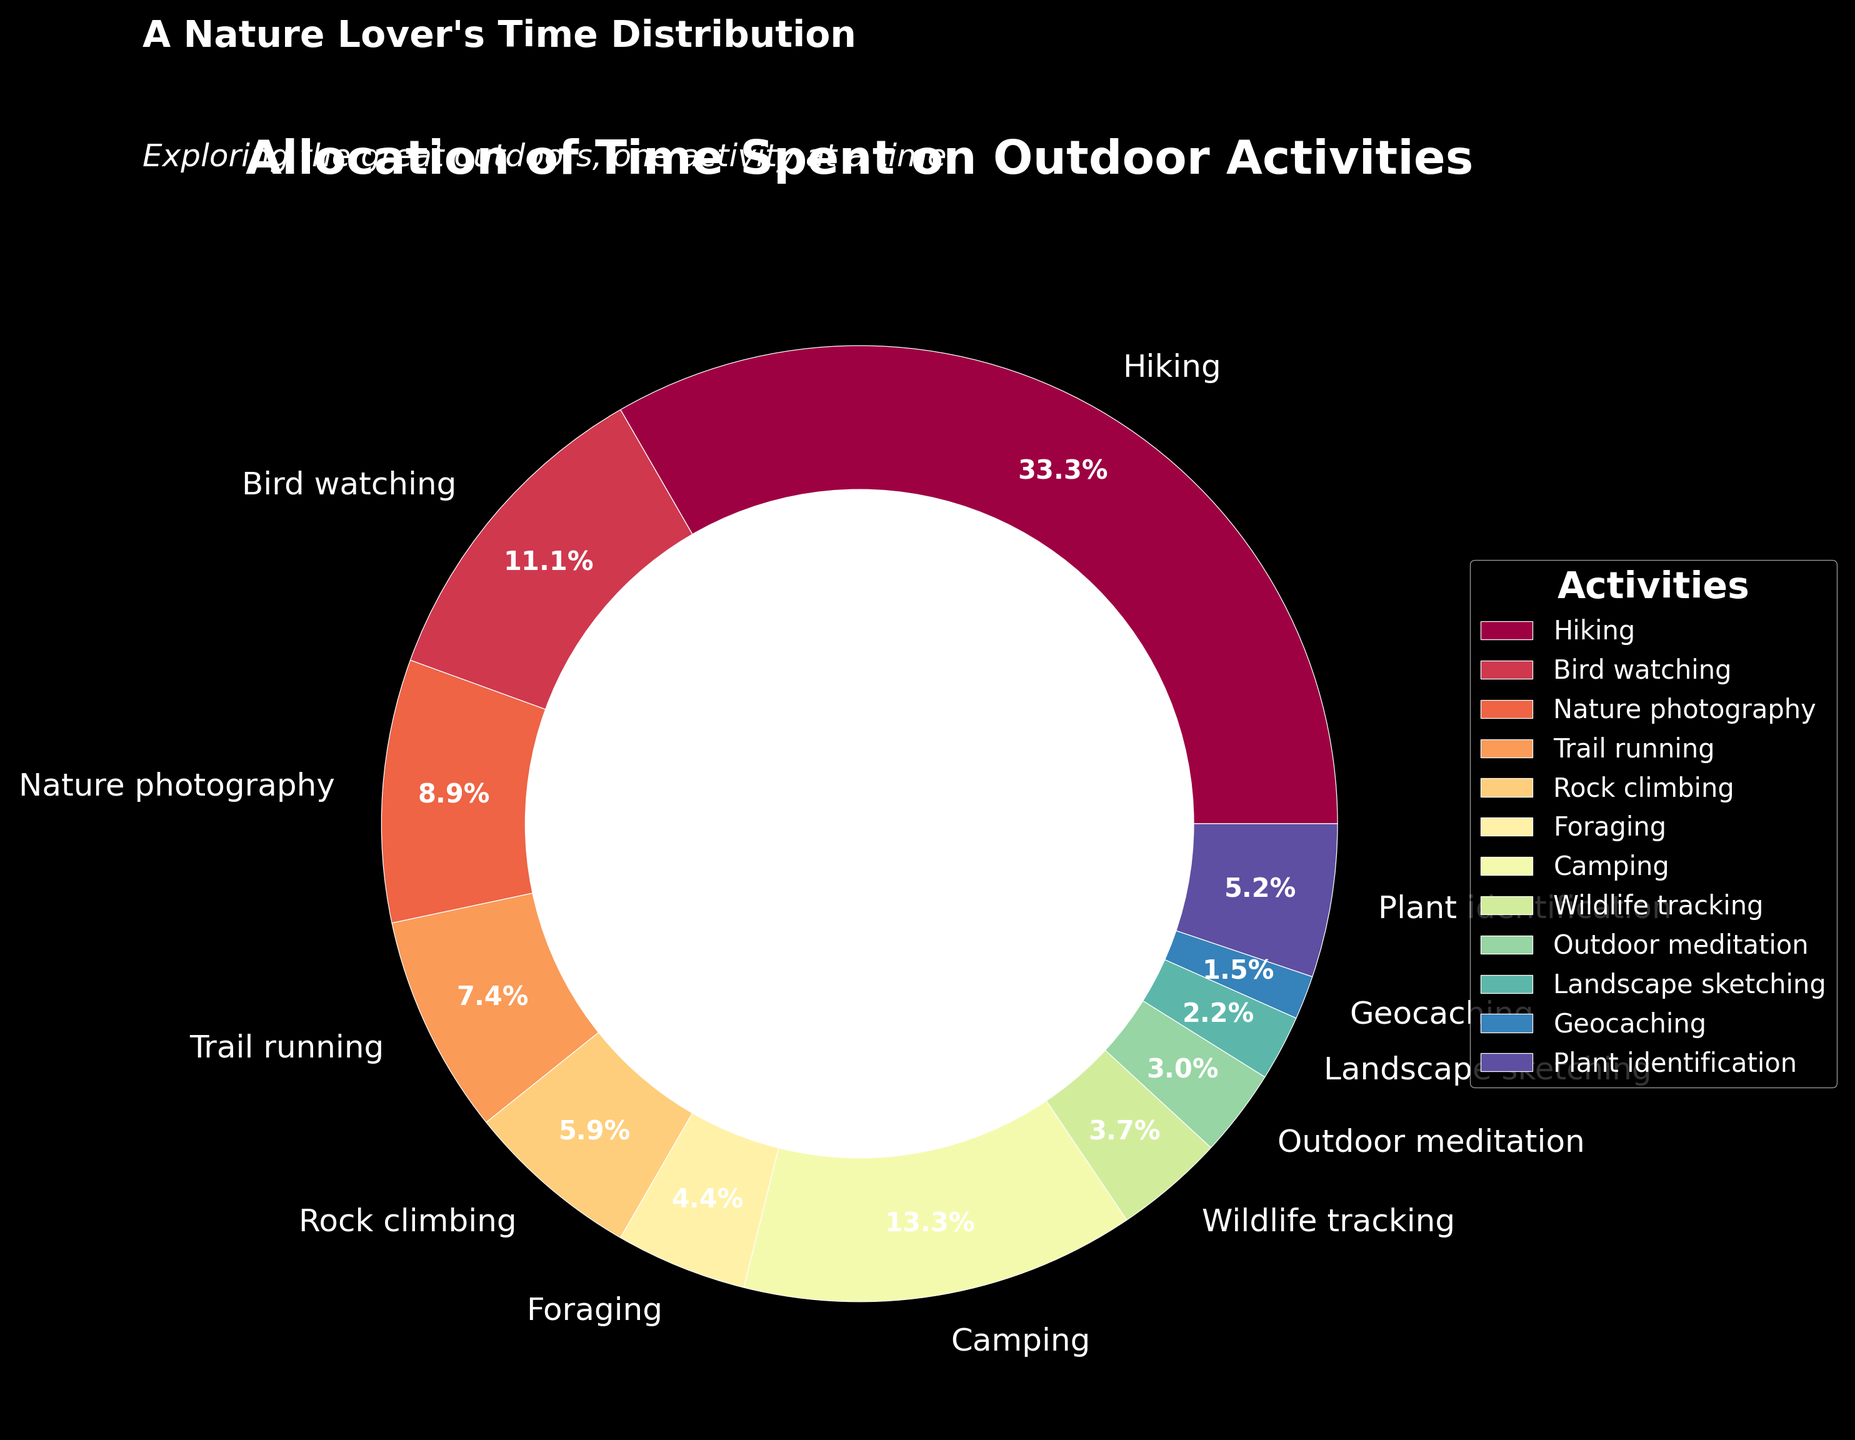What percentage of total time is spent on Camping and Rock climbing combined? First, find the percentage for each activity from the pie chart. Camping is 18 hours out of the total, and Rock climbing is 8 hours. Combined, they sum up to 26 hours. The total hours spent on activities is 135 (by summing all individual hours). Therefore, the percentage is (26 / 135) * 100 ≈ 19.3%
Answer: 19.3% Which activity has the least amount of time allocated, and what percentage of the total does it represent? From the pie chart, Geocaching has the least amount of time allocated, which is 2 hours. The percentage is calculated by (2 / 135) * 100 ≈ 1.5%
Answer: Geocaching, 1.5% How much more time is spent on Hiking compared to Foraging? Hiking is allotted 45 hours, and Foraging is allotted 6 hours. The difference is 45 - 6 = 39 hours
Answer: 39 hours Which activity between Nature photography and Bird watching takes up a larger share in the pie chart, and by how much? Nature Photography is 12 hours, while Bird Watching is 15 hours. Bird Watching takes up a larger share by 15 - 12 = 3 hours
Answer: Bird watching, 3 hours What is the average time spent on the activities that are allocated more than 10 hours? The activities with more than 10 hours are Hiking (45), Bird watching (15), Nature Photography (12), and Camping (18). The total is 45 + 15 + 12 + 18 = 90 hours, and there are 4 such activities. Thus, the average time is 90 / 4 = 22.5 hours
Answer: 22.5 hours Are there more hours spent on Plant identification than on Outdoor meditation? Plant identification is 7 hours, while Outdoor meditation is 4 hours. Hence, more hours are spent on Plant identification
Answer: Yes Which activity occupies the largest slice of the pie chart? Hiking has the largest slice, indicated by both the numerical value (45 hours) and the visual size on the pie chart
Answer: Hiking What is the total time spent on activities involving interaction with wildlife (Foraging, Wildlife tracking, Bird watching)? Sum the hours for Foraging (6), Wildlife tracking (5), and Bird watching (15). Total is 6 + 5 + 15 = 26 hours
Answer: 26 hours What fraction of the total time is identified by activities that are less than 10 hours each? Activities less than 10 hours are Trail running (10), Rock climbing (8), Foraging (6), Wildlife tracking (5), Outdoor meditation (4), Landscape sketching (3), Geocaching (2), and Plant identification (7). Summing these gives 10 + 8 + 6 + 5 + 4 + 3 + 2 + 7 = 45 hours. The fraction is 45 / 135
Answer: 1/3 